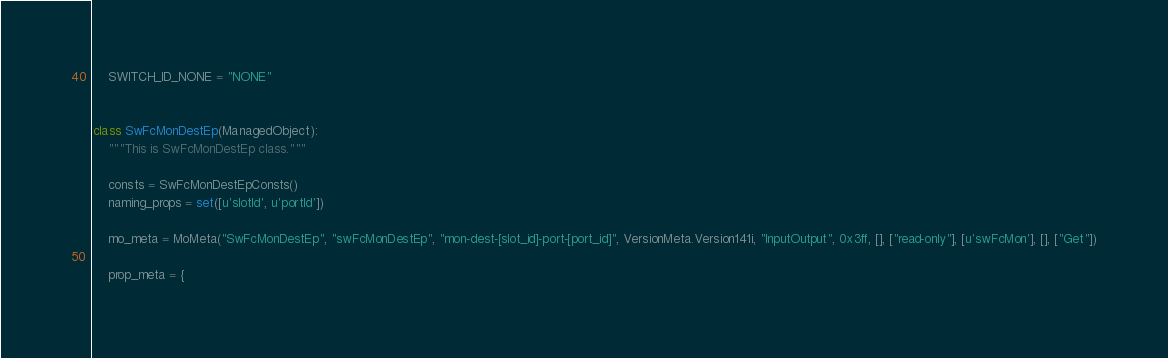<code> <loc_0><loc_0><loc_500><loc_500><_Python_>    SWITCH_ID_NONE = "NONE"


class SwFcMonDestEp(ManagedObject):
    """This is SwFcMonDestEp class."""

    consts = SwFcMonDestEpConsts()
    naming_props = set([u'slotId', u'portId'])

    mo_meta = MoMeta("SwFcMonDestEp", "swFcMonDestEp", "mon-dest-[slot_id]-port-[port_id]", VersionMeta.Version141i, "InputOutput", 0x3ff, [], ["read-only"], [u'swFcMon'], [], ["Get"])

    prop_meta = {</code> 